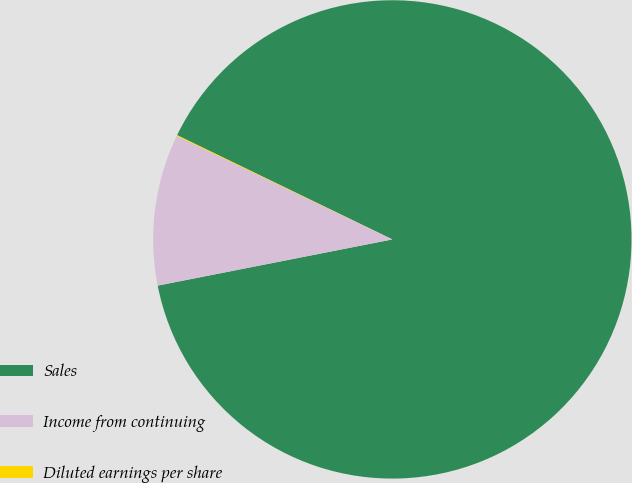Convert chart to OTSL. <chart><loc_0><loc_0><loc_500><loc_500><pie_chart><fcel>Sales<fcel>Income from continuing<fcel>Diluted earnings per share<nl><fcel>89.73%<fcel>10.21%<fcel>0.06%<nl></chart> 